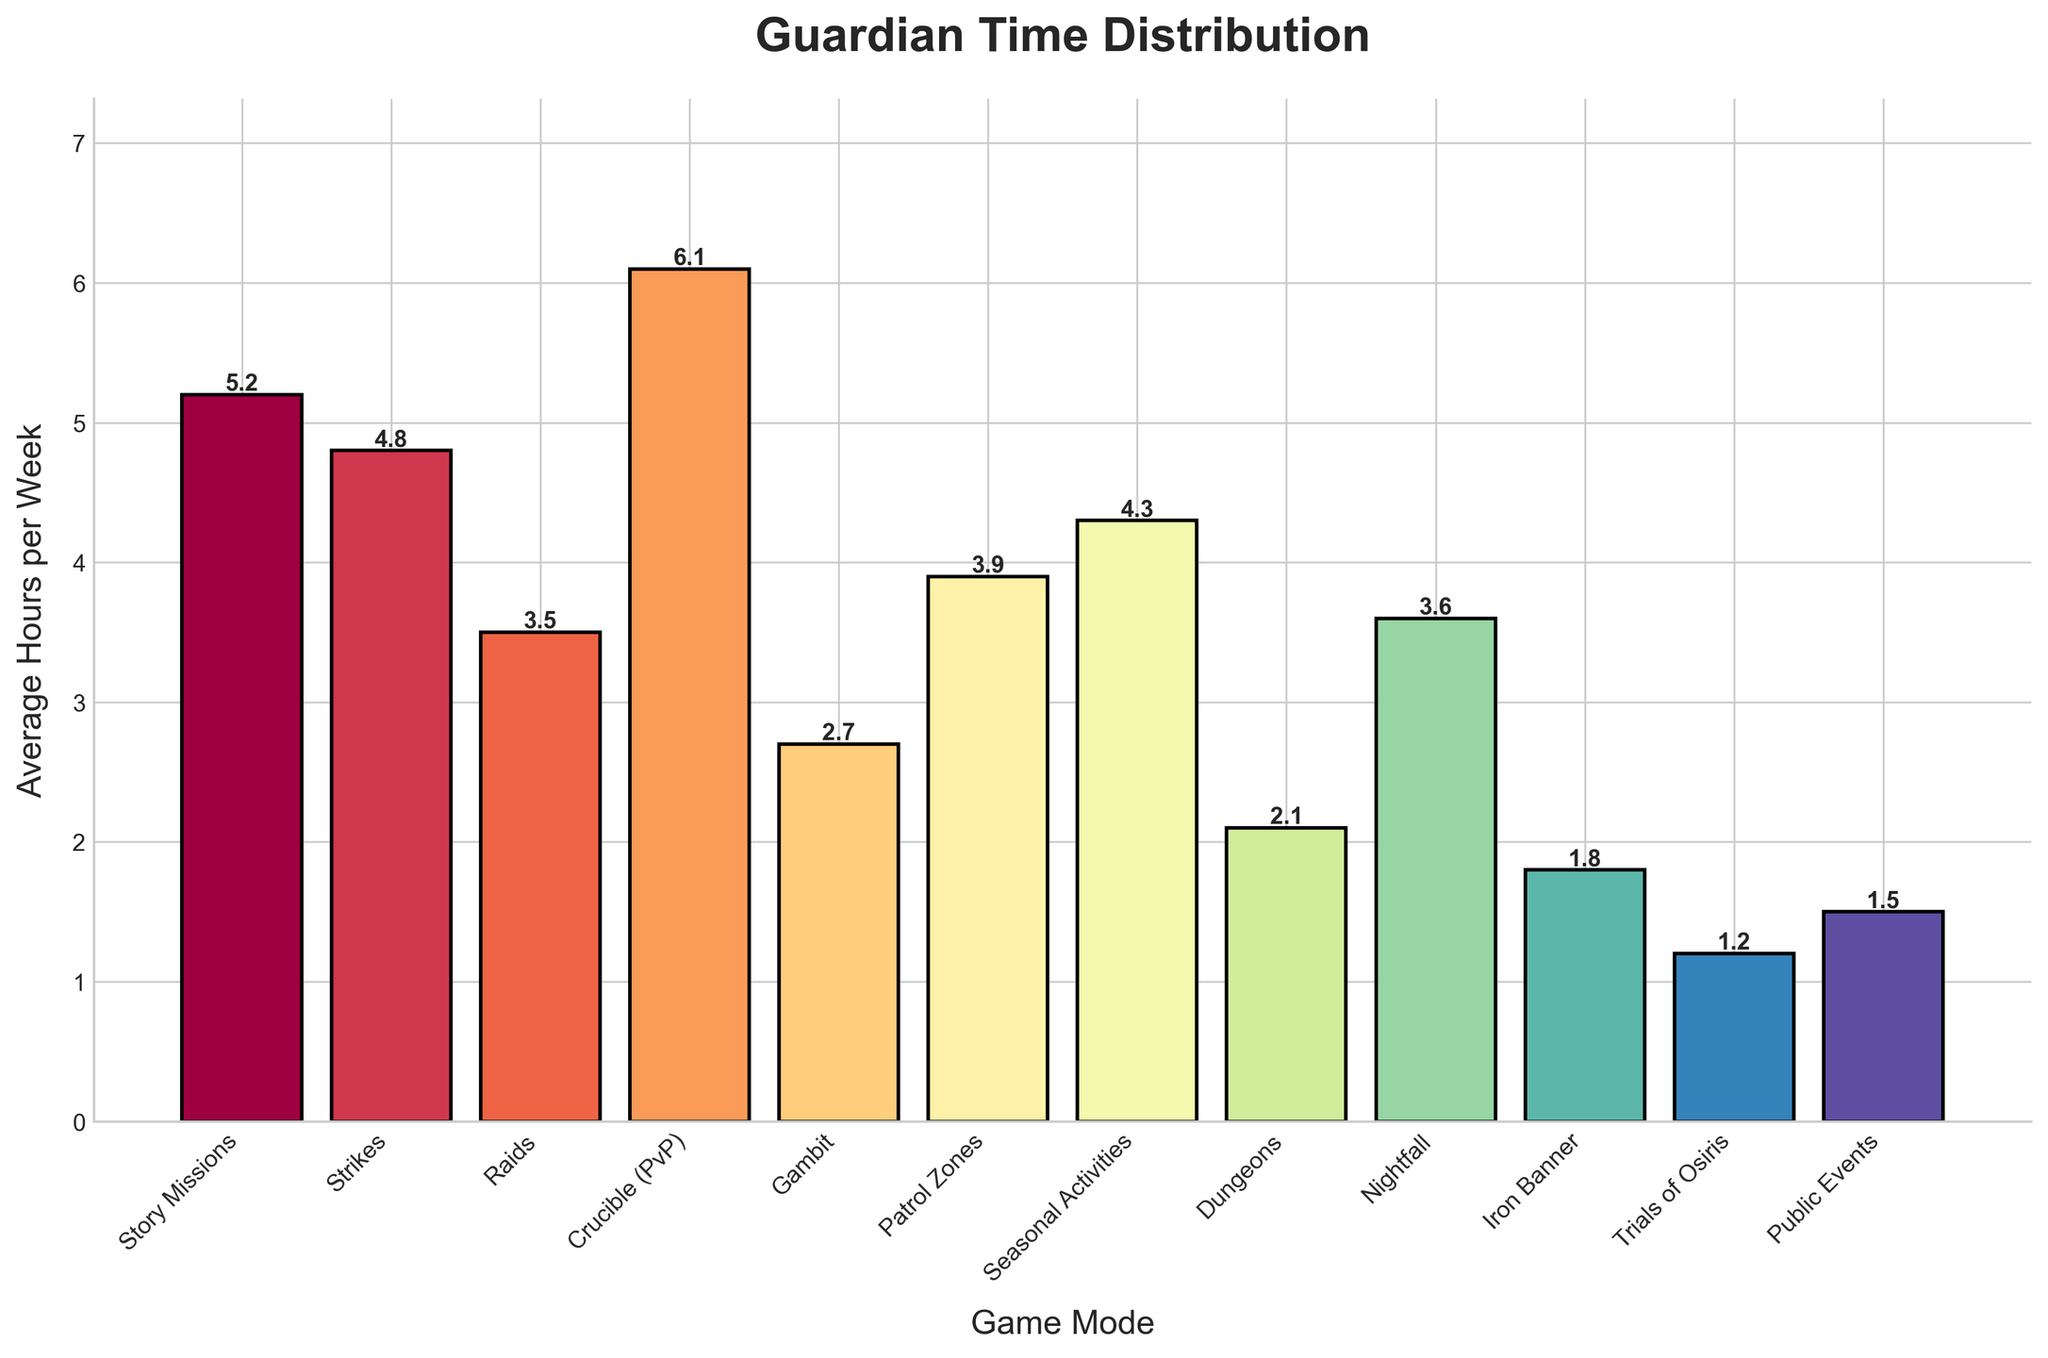Which game mode do players spend the most average hours per week on? Look for the bar that is highest. The tallest bar is labeled "Crucible (PvP)".
Answer: Crucible (PvP) Which two game modes have the closest average hours per week? Compare the bar heights. The bars for "Nightfall" and "Raids" are close, both being around 3.5-3.6 hours.
Answer: Nightfall and Raids What is the sum of average hours per week spent on Story Missions and Strikes? Add the average hours, 5.2 (Story Missions) + 4.8 (Strikes) = 10.0.
Answer: 10.0 How many game modes have an average of more than 4 hours per week? Count the bars that extend above the 4-hour mark. They are "Story Missions," "Strikes," "Crucible (PvP)," and "Seasonal Activities," making 4 in total.
Answer: 4 Which game mode has the lowest average hours per week? Look for the shortest bar. The shortest bar is labeled "Trials of Osiris".
Answer: Trials of Osiris Is the average time spent on Gambit greater than on Iron Banner? Compare the heights of the bars for "Gambit" and "Iron Banner". The Gambit bar is higher (2.7) than the Iron Banner bar (1.8).
Answer: Yes What is the difference in average hours per week between Public Events and Dungeons? Subtract the average hours, 2.1 (Dungeons) - 1.5 (Public Events) = 0.6.
Answer: 0.6 Which game mode has an average of about twice the hours per week spent on Public Events? Double the hours for Public Events (1.5 * 2 = 3). The bar for "Nightfall" is around 3.6, which is close to twice the amount.
Answer: Nightfall Do players spend more average hours per week on Strikes or Patrol Zones? Compare the bar heights for "Strikes" and "Patrol Zones". The Strikes bar (4.8) is higher than the Patrol Zones bar (3.9).
Answer: Strikes What is the total average hours per week spent on all game modes? Add up the average hours for all game modes: 5.2 + 4.8 + 3.5 + 6.1 + 2.7 + 3.9 + 4.3 + 2.1 + 3.6 + 1.8 + 1.2 + 1.5 = 40.7.
Answer: 40.7 